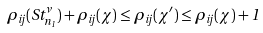<formula> <loc_0><loc_0><loc_500><loc_500>\rho _ { i j } ( S t ^ { \nu } _ { n _ { 1 } } ) + \rho _ { i j } ( \chi ) \leq \rho _ { i j } ( \chi ^ { \prime } ) \leq \rho _ { i j } ( \chi ) + 1</formula> 